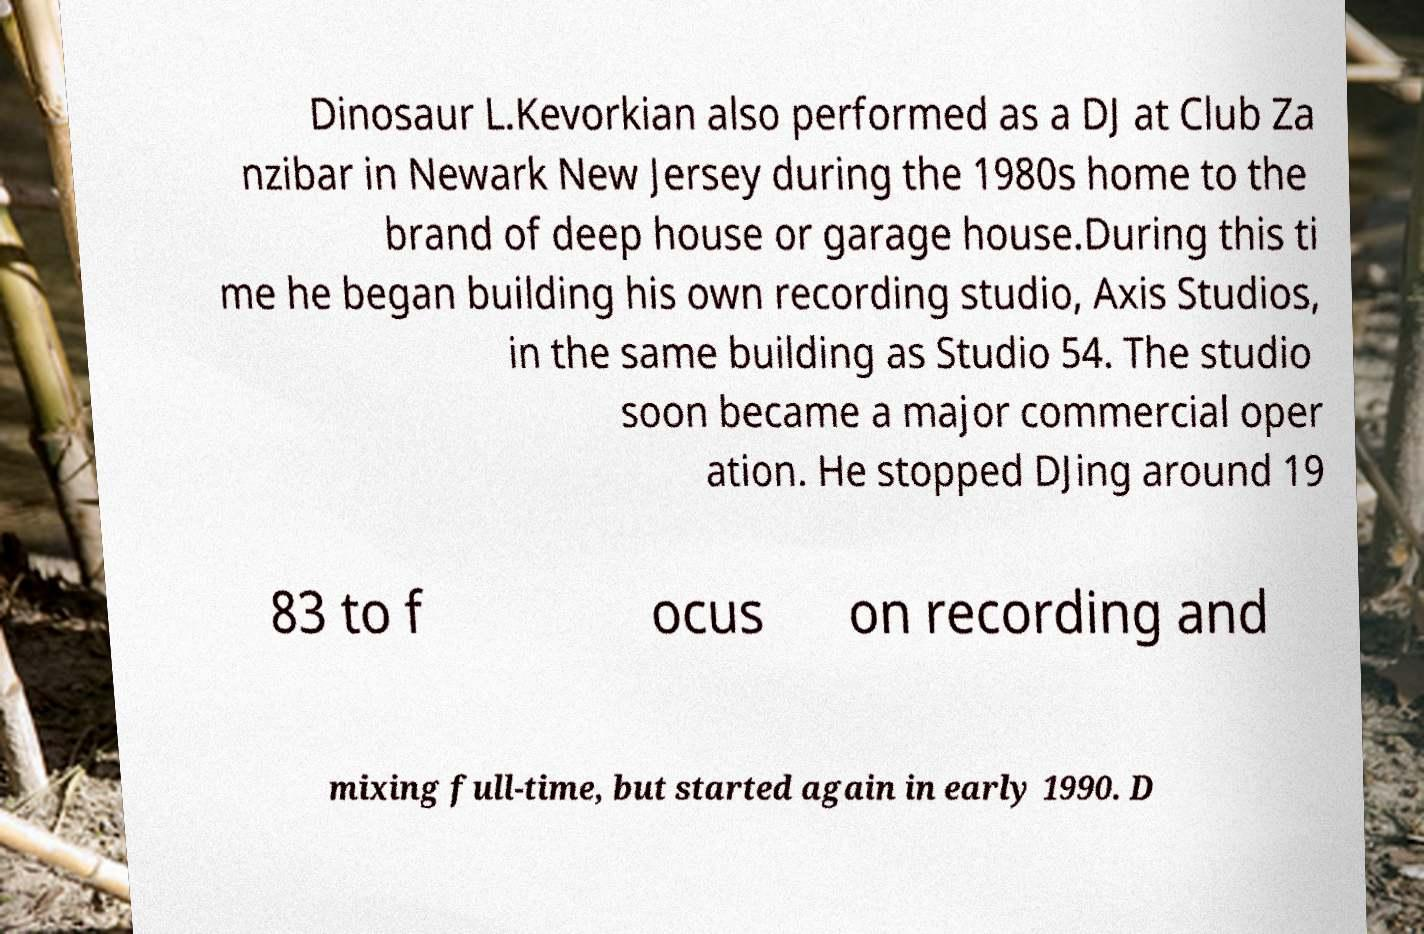Please identify and transcribe the text found in this image. Dinosaur L.Kevorkian also performed as a DJ at Club Za nzibar in Newark New Jersey during the 1980s home to the brand of deep house or garage house.During this ti me he began building his own recording studio, Axis Studios, in the same building as Studio 54. The studio soon became a major commercial oper ation. He stopped DJing around 19 83 to f ocus on recording and mixing full-time, but started again in early 1990. D 